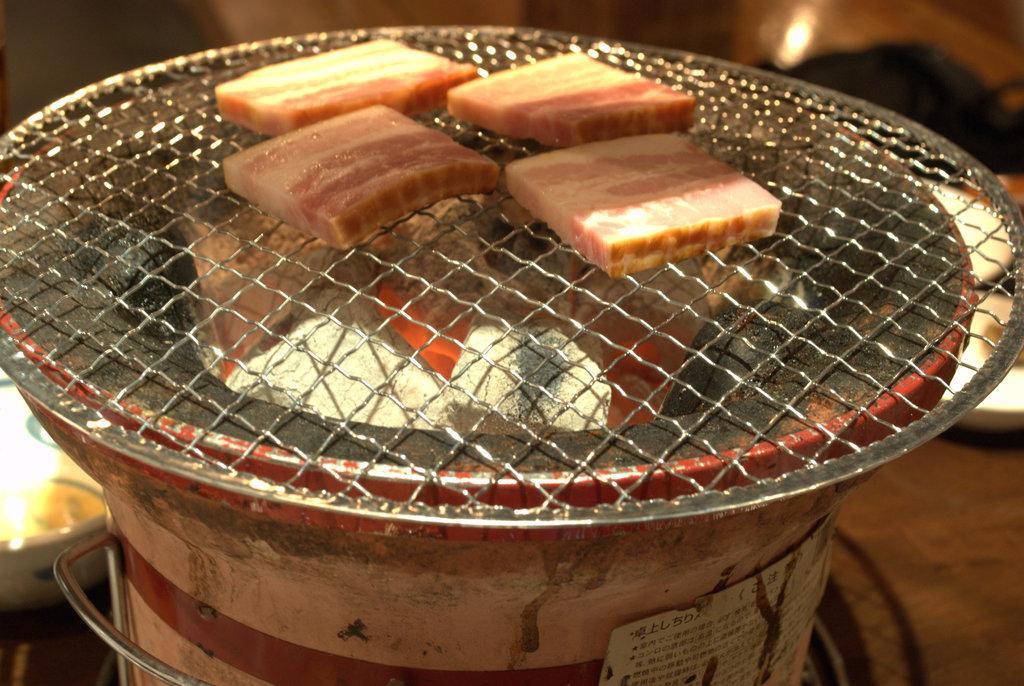Describe this image in one or two sentences. In this picture we can see some food items, steel object and a few coal pieces. We can see some text on a board. There is a bowl on the left side. We can see a few objects in the background. Background is blurry. 